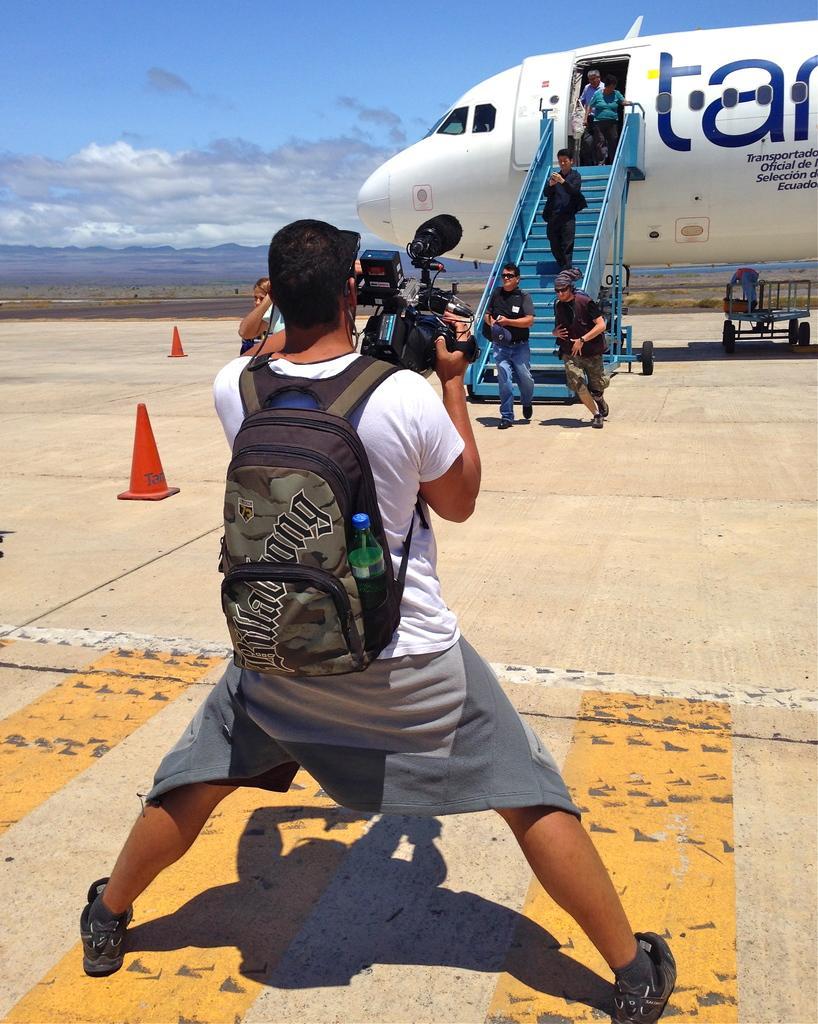Describe this image in one or two sentences. In this image we can see a person standing on the floor holding a camera. On the backside we can see some people getting down of an aeroplane. We can also see some divider poles and the sky which looks cloudy. 